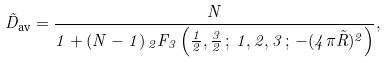Convert formula to latex. <formula><loc_0><loc_0><loc_500><loc_500>\tilde { D } _ { \text {av} } = \frac { N } { 1 + ( N - 1 ) { \, } _ { 2 } F _ { 3 } \left ( \frac { 1 } { 2 } , \frac { 3 } { 2 } \, ; \, 1 , 2 , 3 \, ; \, - ( 4 \pi \tilde { R } ) ^ { 2 } \right ) } ,</formula> 